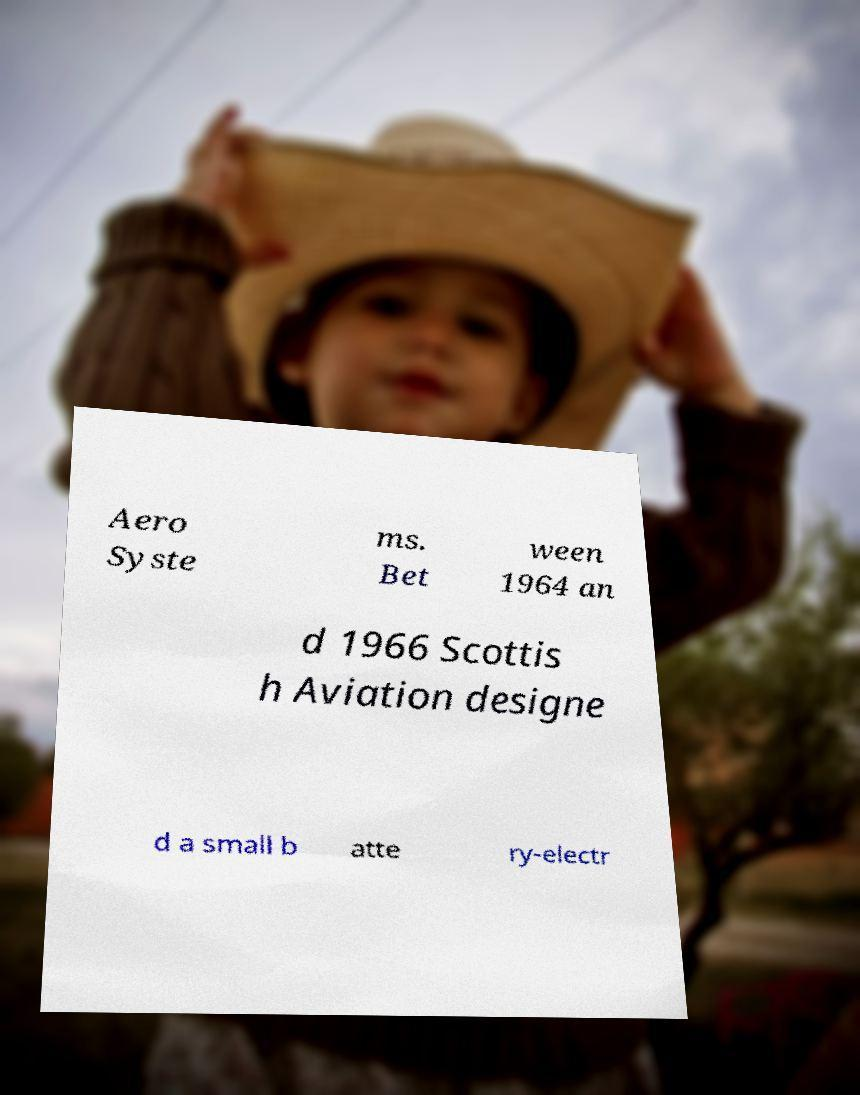Can you accurately transcribe the text from the provided image for me? Aero Syste ms. Bet ween 1964 an d 1966 Scottis h Aviation designe d a small b atte ry-electr 